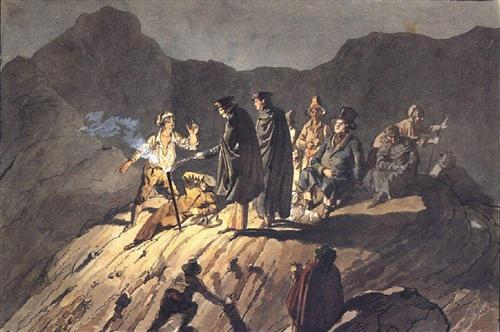Discuss the artistic techniques used in this painting that contribute to its dramatic effect. The artist employs a masterful blend of chiaroscuro and atmospheric perspective to create a visually compelling scene. The use of stark lighting contrasts not only highlights the central figures but also adds a dramatic flair, emphasizing the tension of the moment. The rough, expressive brush strokes enhance the tumultuous nature of the setting and the emotional depth of the characters. Furthermore, the composition, with figures placed at varying depths on the cliff, draws the viewer's eye deeper into the scene, making it more immersive and dynamic. 